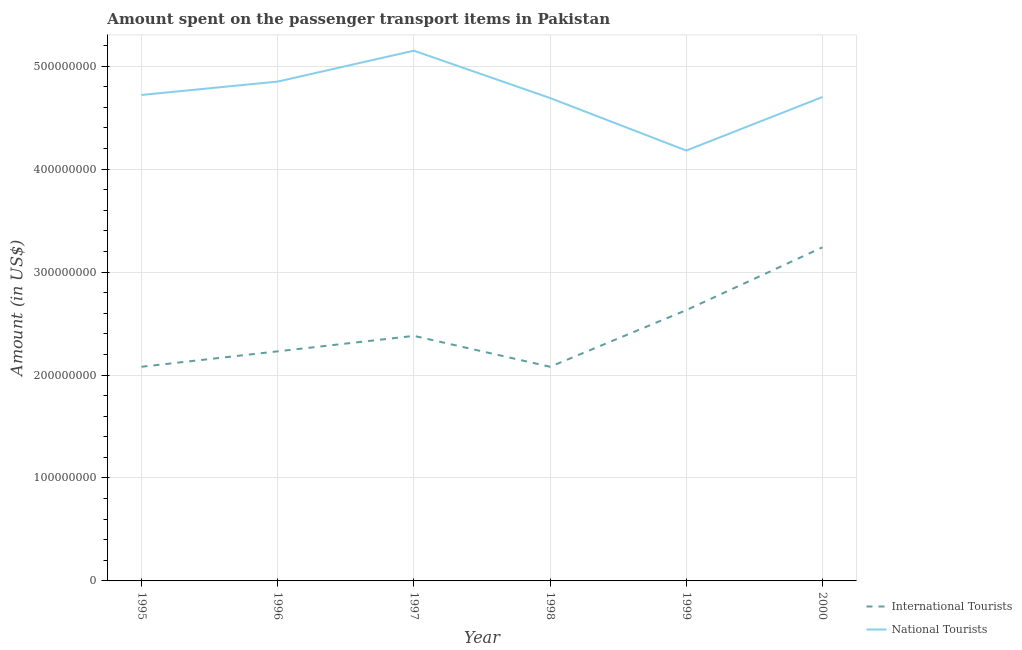Is the number of lines equal to the number of legend labels?
Give a very brief answer. Yes. What is the amount spent on transport items of national tourists in 1996?
Offer a very short reply. 4.85e+08. Across all years, what is the maximum amount spent on transport items of national tourists?
Give a very brief answer. 5.15e+08. Across all years, what is the minimum amount spent on transport items of national tourists?
Offer a very short reply. 4.18e+08. What is the total amount spent on transport items of national tourists in the graph?
Your answer should be very brief. 2.83e+09. What is the difference between the amount spent on transport items of international tourists in 1997 and that in 2000?
Your response must be concise. -8.60e+07. What is the difference between the amount spent on transport items of international tourists in 1999 and the amount spent on transport items of national tourists in 2000?
Make the answer very short. -2.07e+08. What is the average amount spent on transport items of international tourists per year?
Offer a very short reply. 2.44e+08. In the year 1996, what is the difference between the amount spent on transport items of national tourists and amount spent on transport items of international tourists?
Your answer should be very brief. 2.62e+08. In how many years, is the amount spent on transport items of national tourists greater than 280000000 US$?
Your answer should be compact. 6. What is the ratio of the amount spent on transport items of international tourists in 1995 to that in 1996?
Your response must be concise. 0.93. What is the difference between the highest and the second highest amount spent on transport items of national tourists?
Make the answer very short. 3.00e+07. What is the difference between the highest and the lowest amount spent on transport items of international tourists?
Ensure brevity in your answer.  1.16e+08. How many lines are there?
Provide a short and direct response. 2. How many years are there in the graph?
Ensure brevity in your answer.  6. Does the graph contain grids?
Make the answer very short. Yes. What is the title of the graph?
Give a very brief answer. Amount spent on the passenger transport items in Pakistan. What is the label or title of the X-axis?
Offer a very short reply. Year. What is the Amount (in US$) of International Tourists in 1995?
Keep it short and to the point. 2.08e+08. What is the Amount (in US$) of National Tourists in 1995?
Give a very brief answer. 4.72e+08. What is the Amount (in US$) in International Tourists in 1996?
Your answer should be compact. 2.23e+08. What is the Amount (in US$) in National Tourists in 1996?
Offer a very short reply. 4.85e+08. What is the Amount (in US$) in International Tourists in 1997?
Your answer should be very brief. 2.38e+08. What is the Amount (in US$) of National Tourists in 1997?
Keep it short and to the point. 5.15e+08. What is the Amount (in US$) in International Tourists in 1998?
Your answer should be compact. 2.08e+08. What is the Amount (in US$) of National Tourists in 1998?
Provide a short and direct response. 4.69e+08. What is the Amount (in US$) of International Tourists in 1999?
Your answer should be compact. 2.63e+08. What is the Amount (in US$) in National Tourists in 1999?
Give a very brief answer. 4.18e+08. What is the Amount (in US$) in International Tourists in 2000?
Offer a very short reply. 3.24e+08. What is the Amount (in US$) in National Tourists in 2000?
Provide a short and direct response. 4.70e+08. Across all years, what is the maximum Amount (in US$) of International Tourists?
Your answer should be very brief. 3.24e+08. Across all years, what is the maximum Amount (in US$) in National Tourists?
Give a very brief answer. 5.15e+08. Across all years, what is the minimum Amount (in US$) of International Tourists?
Offer a very short reply. 2.08e+08. Across all years, what is the minimum Amount (in US$) in National Tourists?
Your answer should be compact. 4.18e+08. What is the total Amount (in US$) of International Tourists in the graph?
Make the answer very short. 1.46e+09. What is the total Amount (in US$) of National Tourists in the graph?
Offer a very short reply. 2.83e+09. What is the difference between the Amount (in US$) of International Tourists in 1995 and that in 1996?
Provide a short and direct response. -1.50e+07. What is the difference between the Amount (in US$) in National Tourists in 1995 and that in 1996?
Provide a succinct answer. -1.30e+07. What is the difference between the Amount (in US$) of International Tourists in 1995 and that in 1997?
Give a very brief answer. -3.00e+07. What is the difference between the Amount (in US$) of National Tourists in 1995 and that in 1997?
Your answer should be very brief. -4.30e+07. What is the difference between the Amount (in US$) in International Tourists in 1995 and that in 1998?
Provide a succinct answer. 0. What is the difference between the Amount (in US$) in International Tourists in 1995 and that in 1999?
Keep it short and to the point. -5.50e+07. What is the difference between the Amount (in US$) in National Tourists in 1995 and that in 1999?
Your answer should be very brief. 5.40e+07. What is the difference between the Amount (in US$) of International Tourists in 1995 and that in 2000?
Keep it short and to the point. -1.16e+08. What is the difference between the Amount (in US$) in International Tourists in 1996 and that in 1997?
Ensure brevity in your answer.  -1.50e+07. What is the difference between the Amount (in US$) in National Tourists in 1996 and that in 1997?
Your answer should be compact. -3.00e+07. What is the difference between the Amount (in US$) in International Tourists in 1996 and that in 1998?
Make the answer very short. 1.50e+07. What is the difference between the Amount (in US$) in National Tourists in 1996 and that in 1998?
Your answer should be very brief. 1.60e+07. What is the difference between the Amount (in US$) of International Tourists in 1996 and that in 1999?
Offer a very short reply. -4.00e+07. What is the difference between the Amount (in US$) in National Tourists in 1996 and that in 1999?
Ensure brevity in your answer.  6.70e+07. What is the difference between the Amount (in US$) in International Tourists in 1996 and that in 2000?
Provide a short and direct response. -1.01e+08. What is the difference between the Amount (in US$) in National Tourists in 1996 and that in 2000?
Ensure brevity in your answer.  1.50e+07. What is the difference between the Amount (in US$) of International Tourists in 1997 and that in 1998?
Offer a terse response. 3.00e+07. What is the difference between the Amount (in US$) in National Tourists in 1997 and that in 1998?
Offer a very short reply. 4.60e+07. What is the difference between the Amount (in US$) in International Tourists in 1997 and that in 1999?
Keep it short and to the point. -2.50e+07. What is the difference between the Amount (in US$) of National Tourists in 1997 and that in 1999?
Provide a succinct answer. 9.70e+07. What is the difference between the Amount (in US$) in International Tourists in 1997 and that in 2000?
Your answer should be compact. -8.60e+07. What is the difference between the Amount (in US$) of National Tourists in 1997 and that in 2000?
Offer a terse response. 4.50e+07. What is the difference between the Amount (in US$) of International Tourists in 1998 and that in 1999?
Your answer should be very brief. -5.50e+07. What is the difference between the Amount (in US$) in National Tourists in 1998 and that in 1999?
Your response must be concise. 5.10e+07. What is the difference between the Amount (in US$) of International Tourists in 1998 and that in 2000?
Make the answer very short. -1.16e+08. What is the difference between the Amount (in US$) in International Tourists in 1999 and that in 2000?
Offer a terse response. -6.10e+07. What is the difference between the Amount (in US$) of National Tourists in 1999 and that in 2000?
Offer a very short reply. -5.20e+07. What is the difference between the Amount (in US$) of International Tourists in 1995 and the Amount (in US$) of National Tourists in 1996?
Provide a short and direct response. -2.77e+08. What is the difference between the Amount (in US$) of International Tourists in 1995 and the Amount (in US$) of National Tourists in 1997?
Provide a short and direct response. -3.07e+08. What is the difference between the Amount (in US$) in International Tourists in 1995 and the Amount (in US$) in National Tourists in 1998?
Offer a terse response. -2.61e+08. What is the difference between the Amount (in US$) in International Tourists in 1995 and the Amount (in US$) in National Tourists in 1999?
Offer a terse response. -2.10e+08. What is the difference between the Amount (in US$) in International Tourists in 1995 and the Amount (in US$) in National Tourists in 2000?
Ensure brevity in your answer.  -2.62e+08. What is the difference between the Amount (in US$) in International Tourists in 1996 and the Amount (in US$) in National Tourists in 1997?
Keep it short and to the point. -2.92e+08. What is the difference between the Amount (in US$) in International Tourists in 1996 and the Amount (in US$) in National Tourists in 1998?
Your answer should be compact. -2.46e+08. What is the difference between the Amount (in US$) of International Tourists in 1996 and the Amount (in US$) of National Tourists in 1999?
Your answer should be compact. -1.95e+08. What is the difference between the Amount (in US$) in International Tourists in 1996 and the Amount (in US$) in National Tourists in 2000?
Provide a succinct answer. -2.47e+08. What is the difference between the Amount (in US$) of International Tourists in 1997 and the Amount (in US$) of National Tourists in 1998?
Your response must be concise. -2.31e+08. What is the difference between the Amount (in US$) of International Tourists in 1997 and the Amount (in US$) of National Tourists in 1999?
Your answer should be compact. -1.80e+08. What is the difference between the Amount (in US$) of International Tourists in 1997 and the Amount (in US$) of National Tourists in 2000?
Your answer should be compact. -2.32e+08. What is the difference between the Amount (in US$) in International Tourists in 1998 and the Amount (in US$) in National Tourists in 1999?
Ensure brevity in your answer.  -2.10e+08. What is the difference between the Amount (in US$) of International Tourists in 1998 and the Amount (in US$) of National Tourists in 2000?
Your response must be concise. -2.62e+08. What is the difference between the Amount (in US$) of International Tourists in 1999 and the Amount (in US$) of National Tourists in 2000?
Your response must be concise. -2.07e+08. What is the average Amount (in US$) in International Tourists per year?
Provide a short and direct response. 2.44e+08. What is the average Amount (in US$) in National Tourists per year?
Offer a terse response. 4.72e+08. In the year 1995, what is the difference between the Amount (in US$) of International Tourists and Amount (in US$) of National Tourists?
Your answer should be very brief. -2.64e+08. In the year 1996, what is the difference between the Amount (in US$) in International Tourists and Amount (in US$) in National Tourists?
Your answer should be compact. -2.62e+08. In the year 1997, what is the difference between the Amount (in US$) of International Tourists and Amount (in US$) of National Tourists?
Provide a succinct answer. -2.77e+08. In the year 1998, what is the difference between the Amount (in US$) in International Tourists and Amount (in US$) in National Tourists?
Give a very brief answer. -2.61e+08. In the year 1999, what is the difference between the Amount (in US$) of International Tourists and Amount (in US$) of National Tourists?
Make the answer very short. -1.55e+08. In the year 2000, what is the difference between the Amount (in US$) in International Tourists and Amount (in US$) in National Tourists?
Offer a terse response. -1.46e+08. What is the ratio of the Amount (in US$) of International Tourists in 1995 to that in 1996?
Provide a short and direct response. 0.93. What is the ratio of the Amount (in US$) of National Tourists in 1995 to that in 1996?
Your response must be concise. 0.97. What is the ratio of the Amount (in US$) of International Tourists in 1995 to that in 1997?
Provide a succinct answer. 0.87. What is the ratio of the Amount (in US$) of National Tourists in 1995 to that in 1997?
Provide a short and direct response. 0.92. What is the ratio of the Amount (in US$) of International Tourists in 1995 to that in 1998?
Make the answer very short. 1. What is the ratio of the Amount (in US$) of National Tourists in 1995 to that in 1998?
Ensure brevity in your answer.  1.01. What is the ratio of the Amount (in US$) in International Tourists in 1995 to that in 1999?
Provide a short and direct response. 0.79. What is the ratio of the Amount (in US$) of National Tourists in 1995 to that in 1999?
Your answer should be compact. 1.13. What is the ratio of the Amount (in US$) of International Tourists in 1995 to that in 2000?
Make the answer very short. 0.64. What is the ratio of the Amount (in US$) in International Tourists in 1996 to that in 1997?
Offer a terse response. 0.94. What is the ratio of the Amount (in US$) of National Tourists in 1996 to that in 1997?
Your answer should be compact. 0.94. What is the ratio of the Amount (in US$) of International Tourists in 1996 to that in 1998?
Offer a very short reply. 1.07. What is the ratio of the Amount (in US$) of National Tourists in 1996 to that in 1998?
Offer a very short reply. 1.03. What is the ratio of the Amount (in US$) of International Tourists in 1996 to that in 1999?
Your answer should be compact. 0.85. What is the ratio of the Amount (in US$) of National Tourists in 1996 to that in 1999?
Make the answer very short. 1.16. What is the ratio of the Amount (in US$) of International Tourists in 1996 to that in 2000?
Keep it short and to the point. 0.69. What is the ratio of the Amount (in US$) in National Tourists in 1996 to that in 2000?
Offer a very short reply. 1.03. What is the ratio of the Amount (in US$) of International Tourists in 1997 to that in 1998?
Your answer should be compact. 1.14. What is the ratio of the Amount (in US$) in National Tourists in 1997 to that in 1998?
Offer a very short reply. 1.1. What is the ratio of the Amount (in US$) of International Tourists in 1997 to that in 1999?
Your response must be concise. 0.9. What is the ratio of the Amount (in US$) in National Tourists in 1997 to that in 1999?
Offer a very short reply. 1.23. What is the ratio of the Amount (in US$) in International Tourists in 1997 to that in 2000?
Your response must be concise. 0.73. What is the ratio of the Amount (in US$) of National Tourists in 1997 to that in 2000?
Offer a very short reply. 1.1. What is the ratio of the Amount (in US$) in International Tourists in 1998 to that in 1999?
Provide a succinct answer. 0.79. What is the ratio of the Amount (in US$) of National Tourists in 1998 to that in 1999?
Give a very brief answer. 1.12. What is the ratio of the Amount (in US$) in International Tourists in 1998 to that in 2000?
Make the answer very short. 0.64. What is the ratio of the Amount (in US$) in International Tourists in 1999 to that in 2000?
Your answer should be compact. 0.81. What is the ratio of the Amount (in US$) in National Tourists in 1999 to that in 2000?
Your response must be concise. 0.89. What is the difference between the highest and the second highest Amount (in US$) in International Tourists?
Provide a short and direct response. 6.10e+07. What is the difference between the highest and the second highest Amount (in US$) of National Tourists?
Keep it short and to the point. 3.00e+07. What is the difference between the highest and the lowest Amount (in US$) in International Tourists?
Provide a short and direct response. 1.16e+08. What is the difference between the highest and the lowest Amount (in US$) of National Tourists?
Provide a succinct answer. 9.70e+07. 